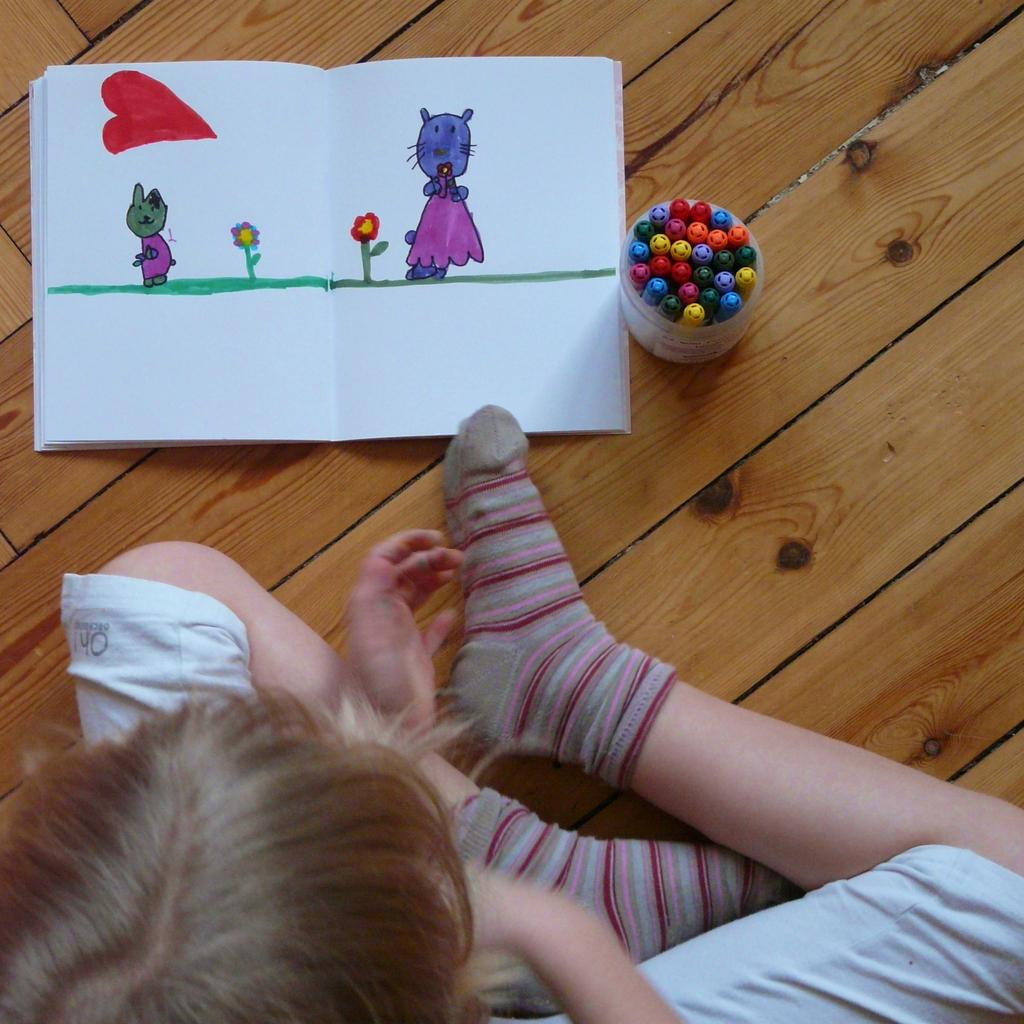What is the person in the image doing? There is a person sitting in the image. What can be seen on the book that the person is holding? There are drawings of cats and flowers on the book. Where are the pens located in the image? The pens are in a box. What material is the floor made of in the image? The floor is made of wood. What type of goose can be seen walking on the side of the person in the image? There is no goose present in the image. What is the current temperature in the room where the image was taken? The provided facts do not give any information about the temperature in the room, so it cannot be determined from the image. 